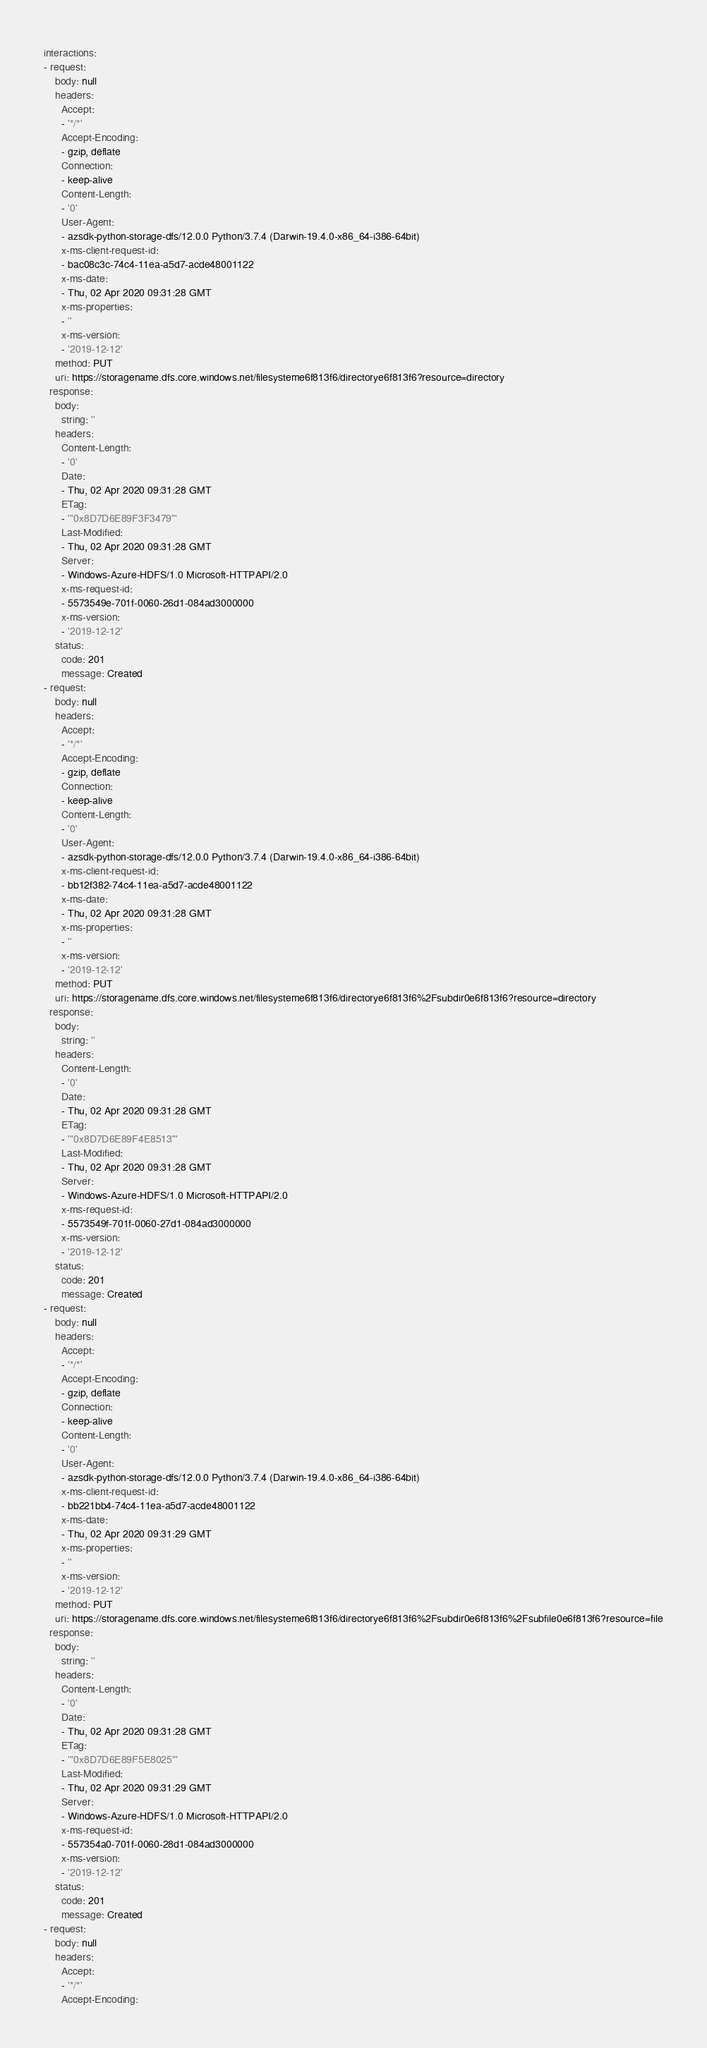<code> <loc_0><loc_0><loc_500><loc_500><_YAML_>interactions:
- request:
    body: null
    headers:
      Accept:
      - '*/*'
      Accept-Encoding:
      - gzip, deflate
      Connection:
      - keep-alive
      Content-Length:
      - '0'
      User-Agent:
      - azsdk-python-storage-dfs/12.0.0 Python/3.7.4 (Darwin-19.4.0-x86_64-i386-64bit)
      x-ms-client-request-id:
      - bac08c3c-74c4-11ea-a5d7-acde48001122
      x-ms-date:
      - Thu, 02 Apr 2020 09:31:28 GMT
      x-ms-properties:
      - ''
      x-ms-version:
      - '2019-12-12'
    method: PUT
    uri: https://storagename.dfs.core.windows.net/filesysteme6f813f6/directorye6f813f6?resource=directory
  response:
    body:
      string: ''
    headers:
      Content-Length:
      - '0'
      Date:
      - Thu, 02 Apr 2020 09:31:28 GMT
      ETag:
      - '"0x8D7D6E89F3F3479"'
      Last-Modified:
      - Thu, 02 Apr 2020 09:31:28 GMT
      Server:
      - Windows-Azure-HDFS/1.0 Microsoft-HTTPAPI/2.0
      x-ms-request-id:
      - 5573549e-701f-0060-26d1-084ad3000000
      x-ms-version:
      - '2019-12-12'
    status:
      code: 201
      message: Created
- request:
    body: null
    headers:
      Accept:
      - '*/*'
      Accept-Encoding:
      - gzip, deflate
      Connection:
      - keep-alive
      Content-Length:
      - '0'
      User-Agent:
      - azsdk-python-storage-dfs/12.0.0 Python/3.7.4 (Darwin-19.4.0-x86_64-i386-64bit)
      x-ms-client-request-id:
      - bb12f382-74c4-11ea-a5d7-acde48001122
      x-ms-date:
      - Thu, 02 Apr 2020 09:31:28 GMT
      x-ms-properties:
      - ''
      x-ms-version:
      - '2019-12-12'
    method: PUT
    uri: https://storagename.dfs.core.windows.net/filesysteme6f813f6/directorye6f813f6%2Fsubdir0e6f813f6?resource=directory
  response:
    body:
      string: ''
    headers:
      Content-Length:
      - '0'
      Date:
      - Thu, 02 Apr 2020 09:31:28 GMT
      ETag:
      - '"0x8D7D6E89F4E8513"'
      Last-Modified:
      - Thu, 02 Apr 2020 09:31:28 GMT
      Server:
      - Windows-Azure-HDFS/1.0 Microsoft-HTTPAPI/2.0
      x-ms-request-id:
      - 5573549f-701f-0060-27d1-084ad3000000
      x-ms-version:
      - '2019-12-12'
    status:
      code: 201
      message: Created
- request:
    body: null
    headers:
      Accept:
      - '*/*'
      Accept-Encoding:
      - gzip, deflate
      Connection:
      - keep-alive
      Content-Length:
      - '0'
      User-Agent:
      - azsdk-python-storage-dfs/12.0.0 Python/3.7.4 (Darwin-19.4.0-x86_64-i386-64bit)
      x-ms-client-request-id:
      - bb221bb4-74c4-11ea-a5d7-acde48001122
      x-ms-date:
      - Thu, 02 Apr 2020 09:31:29 GMT
      x-ms-properties:
      - ''
      x-ms-version:
      - '2019-12-12'
    method: PUT
    uri: https://storagename.dfs.core.windows.net/filesysteme6f813f6/directorye6f813f6%2Fsubdir0e6f813f6%2Fsubfile0e6f813f6?resource=file
  response:
    body:
      string: ''
    headers:
      Content-Length:
      - '0'
      Date:
      - Thu, 02 Apr 2020 09:31:28 GMT
      ETag:
      - '"0x8D7D6E89F5E8025"'
      Last-Modified:
      - Thu, 02 Apr 2020 09:31:29 GMT
      Server:
      - Windows-Azure-HDFS/1.0 Microsoft-HTTPAPI/2.0
      x-ms-request-id:
      - 557354a0-701f-0060-28d1-084ad3000000
      x-ms-version:
      - '2019-12-12'
    status:
      code: 201
      message: Created
- request:
    body: null
    headers:
      Accept:
      - '*/*'
      Accept-Encoding:</code> 